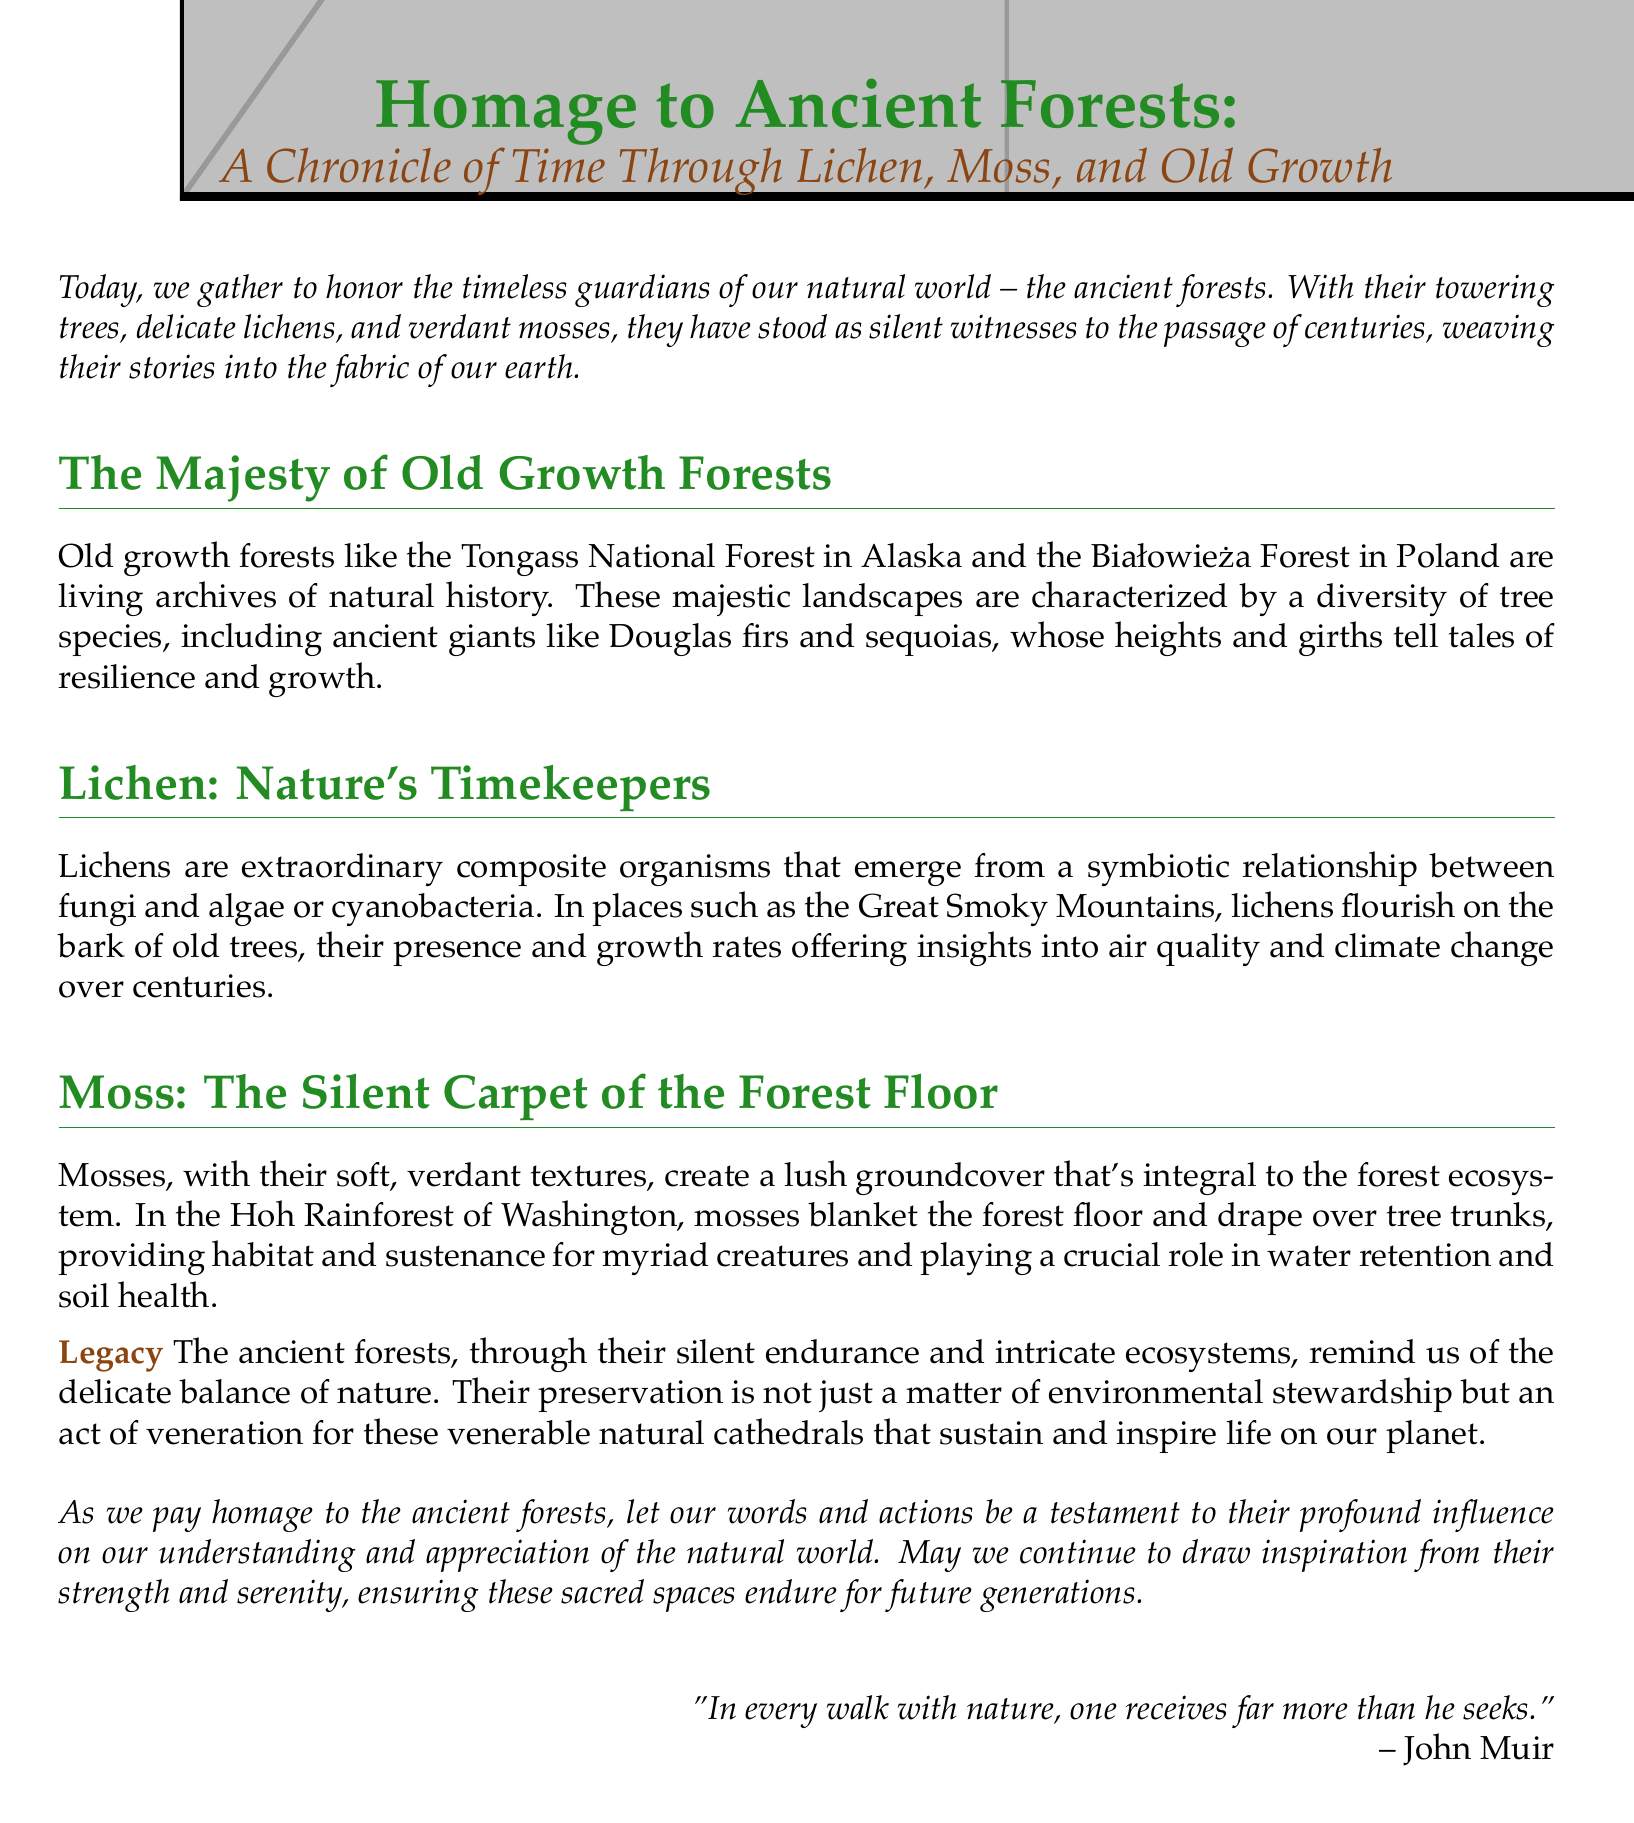What is the title of the document? The title is prominently displayed at the beginning of the document.
Answer: Homage to Ancient Forests: A Chronicle of Time Through Lichen, Moss, and Old Growth Which forests are mentioned as examples of old growth forests? The document names specific forests as examples of old growth forests.
Answer: Tongass National Forest, Białowieża Forest What role do lichens play in understanding environmental changes? The document discusses the significance of lichens in relation to climate and air quality.
Answer: Timekeepers In which location do lichens flourish on old trees, according to the document? The document specifies where lichens grow abundantly.
Answer: Great Smoky Mountains What is the function of mosses in the forest ecosystem? The document outlines the importance of mosses to the ecosystem, highlighting multiple functions.
Answer: Water retention, soil health Who is quoted at the end of the document? The document includes a quote to emphasize a connection with nature.
Answer: John Muir What type of organisms are lichens? The document explains the categorization of lichens within the natural world.
Answer: Composite organisms What color is used for the title in the document? The title's color is specified in the document's formatting.
Answer: Forest green 